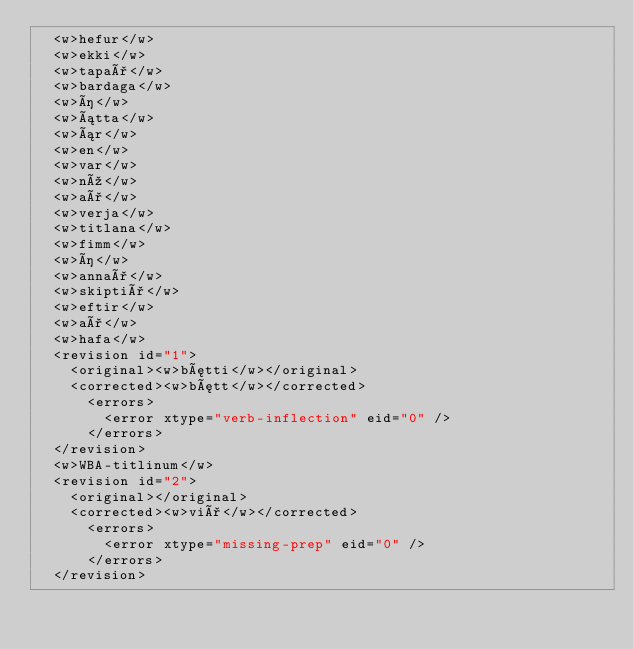<code> <loc_0><loc_0><loc_500><loc_500><_XML_>  <w>hefur</w>
  <w>ekki</w>
  <w>tapað</w>
  <w>bardaga</w>
  <w>í</w>
  <w>átta</w>
  <w>ár</w>
  <w>en</w>
  <w>var</w>
  <w>nú</w>
  <w>að</w>
  <w>verja</w>
  <w>titlana</w>
  <w>fimm</w>
  <w>í</w>
  <w>annað</w>
  <w>skiptið</w>
  <w>eftir</w>
  <w>að</w>
  <w>hafa</w>
  <revision id="1">
    <original><w>bætti</w></original>
    <corrected><w>bætt</w></corrected>
      <errors>
        <error xtype="verb-inflection" eid="0" />
      </errors>
  </revision>
  <w>WBA-titlinum</w>
  <revision id="2">
    <original></original>
    <corrected><w>við</w></corrected>
      <errors>
        <error xtype="missing-prep" eid="0" />
      </errors>
  </revision></code> 